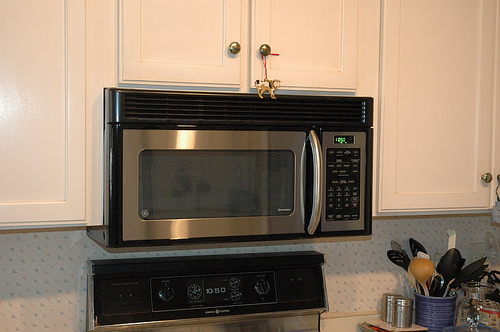Read all the text in this image. 50 